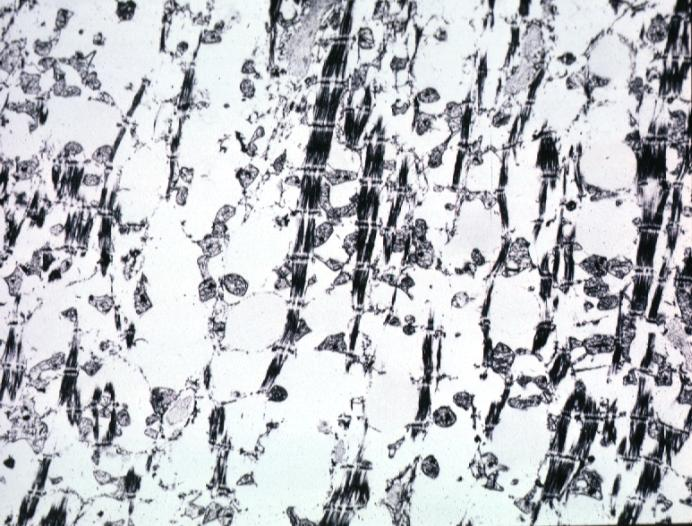what is present?
Answer the question using a single word or phrase. Cardiovascular 